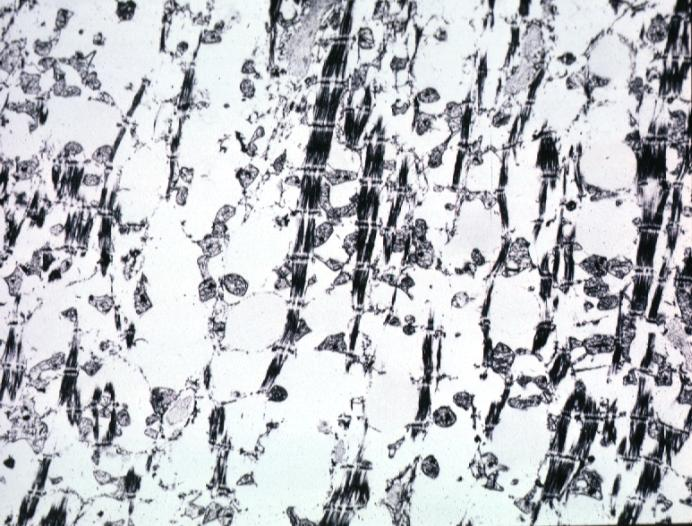what is present?
Answer the question using a single word or phrase. Cardiovascular 